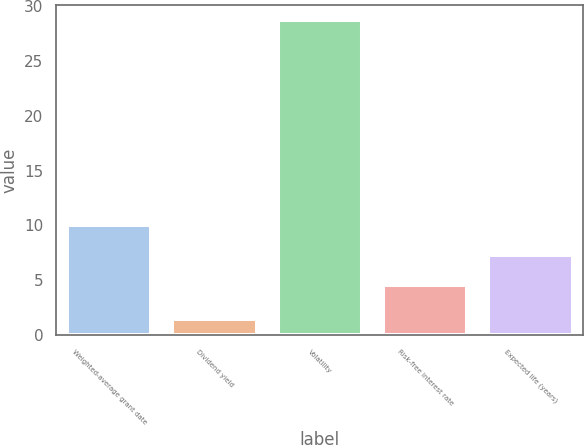Convert chart. <chart><loc_0><loc_0><loc_500><loc_500><bar_chart><fcel>Weighted-average grant date<fcel>Dividend yield<fcel>Volatility<fcel>Risk-free interest rate<fcel>Expected life (years)<nl><fcel>10.04<fcel>1.5<fcel>28.7<fcel>4.6<fcel>7.32<nl></chart> 